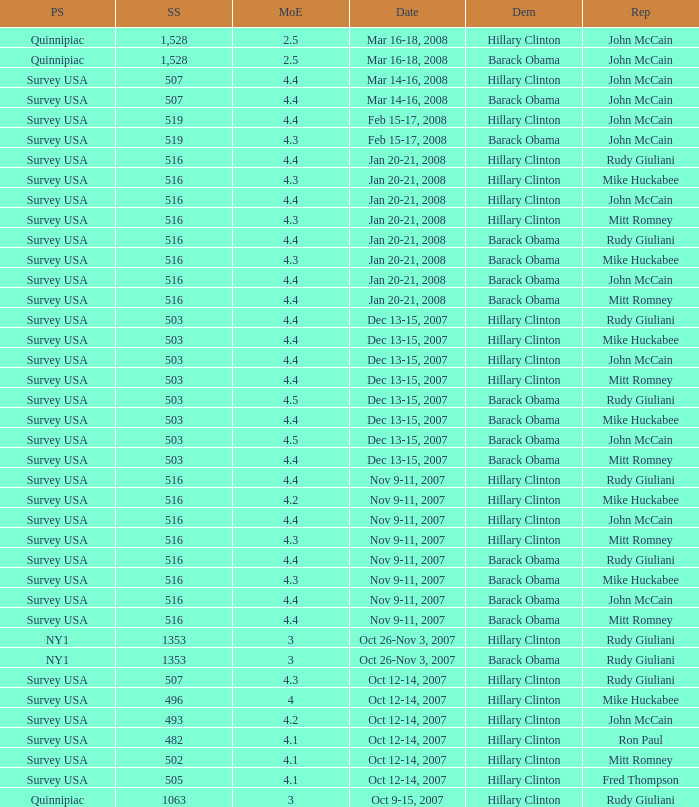What is the sample size of the poll taken on Dec 13-15, 2007 that had a margin of error of more than 4 and resulted with Republican Mike Huckabee? 503.0. 